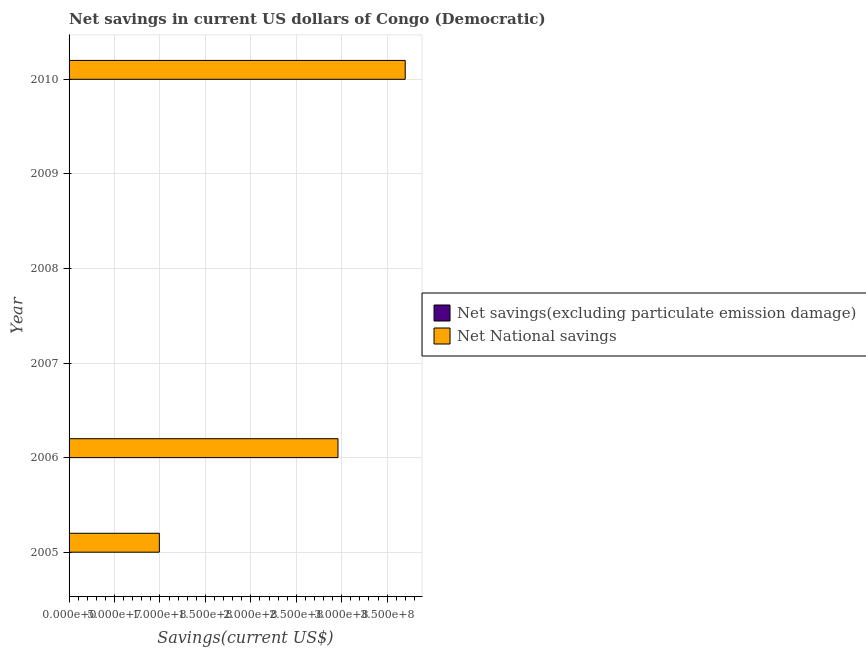How many different coloured bars are there?
Offer a terse response. 1. In how many cases, is the number of bars for a given year not equal to the number of legend labels?
Offer a terse response. 6. Across all years, what is the maximum net national savings?
Give a very brief answer. 3.70e+08. Across all years, what is the minimum net national savings?
Make the answer very short. 0. In which year was the net national savings maximum?
Provide a succinct answer. 2010. What is the difference between the net national savings in 2009 and the net savings(excluding particulate emission damage) in 2006?
Give a very brief answer. 0. What is the average net national savings per year?
Your answer should be very brief. 1.28e+08. In how many years, is the net savings(excluding particulate emission damage) greater than 280000000 US$?
Your answer should be very brief. 0. Is the net national savings in 2005 less than that in 2010?
Ensure brevity in your answer.  Yes. What is the difference between the highest and the second highest net national savings?
Offer a terse response. 7.40e+07. What is the difference between the highest and the lowest net national savings?
Your answer should be compact. 3.70e+08. How many bars are there?
Ensure brevity in your answer.  3. What is the difference between two consecutive major ticks on the X-axis?
Provide a short and direct response. 5.00e+07. Are the values on the major ticks of X-axis written in scientific E-notation?
Provide a succinct answer. Yes. Does the graph contain any zero values?
Offer a terse response. Yes. Where does the legend appear in the graph?
Give a very brief answer. Center right. How many legend labels are there?
Keep it short and to the point. 2. What is the title of the graph?
Offer a very short reply. Net savings in current US dollars of Congo (Democratic). What is the label or title of the X-axis?
Your answer should be very brief. Savings(current US$). What is the label or title of the Y-axis?
Offer a very short reply. Year. What is the Savings(current US$) of Net National savings in 2005?
Keep it short and to the point. 9.93e+07. What is the Savings(current US$) in Net National savings in 2006?
Make the answer very short. 2.96e+08. What is the Savings(current US$) in Net National savings in 2007?
Provide a short and direct response. 0. What is the Savings(current US$) in Net savings(excluding particulate emission damage) in 2009?
Ensure brevity in your answer.  0. What is the Savings(current US$) in Net National savings in 2009?
Your answer should be very brief. 0. What is the Savings(current US$) of Net National savings in 2010?
Provide a succinct answer. 3.70e+08. Across all years, what is the maximum Savings(current US$) in Net National savings?
Make the answer very short. 3.70e+08. Across all years, what is the minimum Savings(current US$) of Net National savings?
Provide a succinct answer. 0. What is the total Savings(current US$) of Net National savings in the graph?
Provide a succinct answer. 7.65e+08. What is the difference between the Savings(current US$) in Net National savings in 2005 and that in 2006?
Provide a short and direct response. -1.97e+08. What is the difference between the Savings(current US$) in Net National savings in 2005 and that in 2010?
Ensure brevity in your answer.  -2.71e+08. What is the difference between the Savings(current US$) of Net National savings in 2006 and that in 2010?
Offer a very short reply. -7.40e+07. What is the average Savings(current US$) in Net National savings per year?
Give a very brief answer. 1.28e+08. What is the ratio of the Savings(current US$) in Net National savings in 2005 to that in 2006?
Your response must be concise. 0.34. What is the ratio of the Savings(current US$) of Net National savings in 2005 to that in 2010?
Your answer should be very brief. 0.27. What is the ratio of the Savings(current US$) of Net National savings in 2006 to that in 2010?
Ensure brevity in your answer.  0.8. What is the difference between the highest and the second highest Savings(current US$) in Net National savings?
Offer a very short reply. 7.40e+07. What is the difference between the highest and the lowest Savings(current US$) of Net National savings?
Keep it short and to the point. 3.70e+08. 